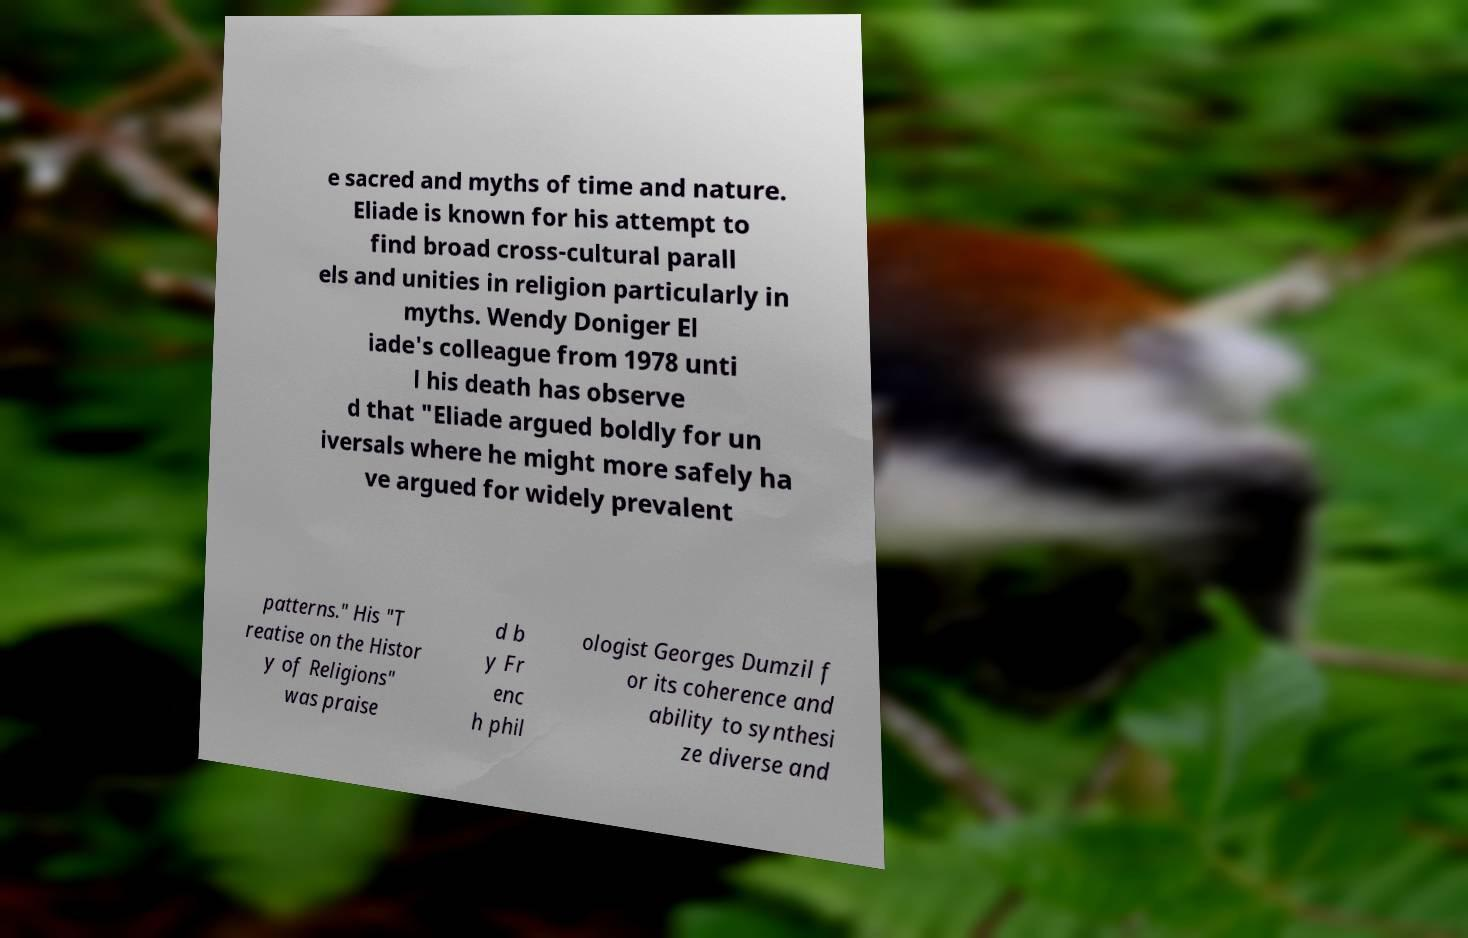For documentation purposes, I need the text within this image transcribed. Could you provide that? e sacred and myths of time and nature. Eliade is known for his attempt to find broad cross-cultural parall els and unities in religion particularly in myths. Wendy Doniger El iade's colleague from 1978 unti l his death has observe d that "Eliade argued boldly for un iversals where he might more safely ha ve argued for widely prevalent patterns." His "T reatise on the Histor y of Religions" was praise d b y Fr enc h phil ologist Georges Dumzil f or its coherence and ability to synthesi ze diverse and 